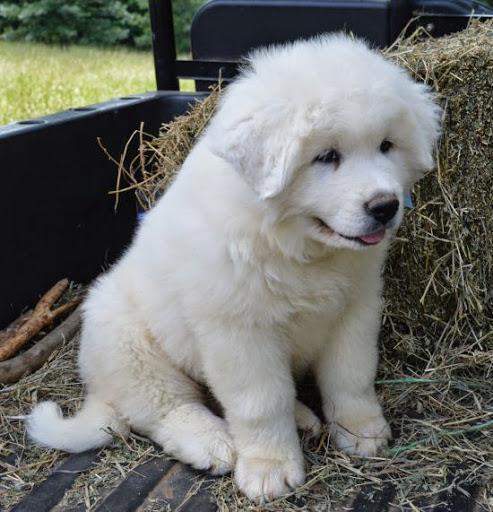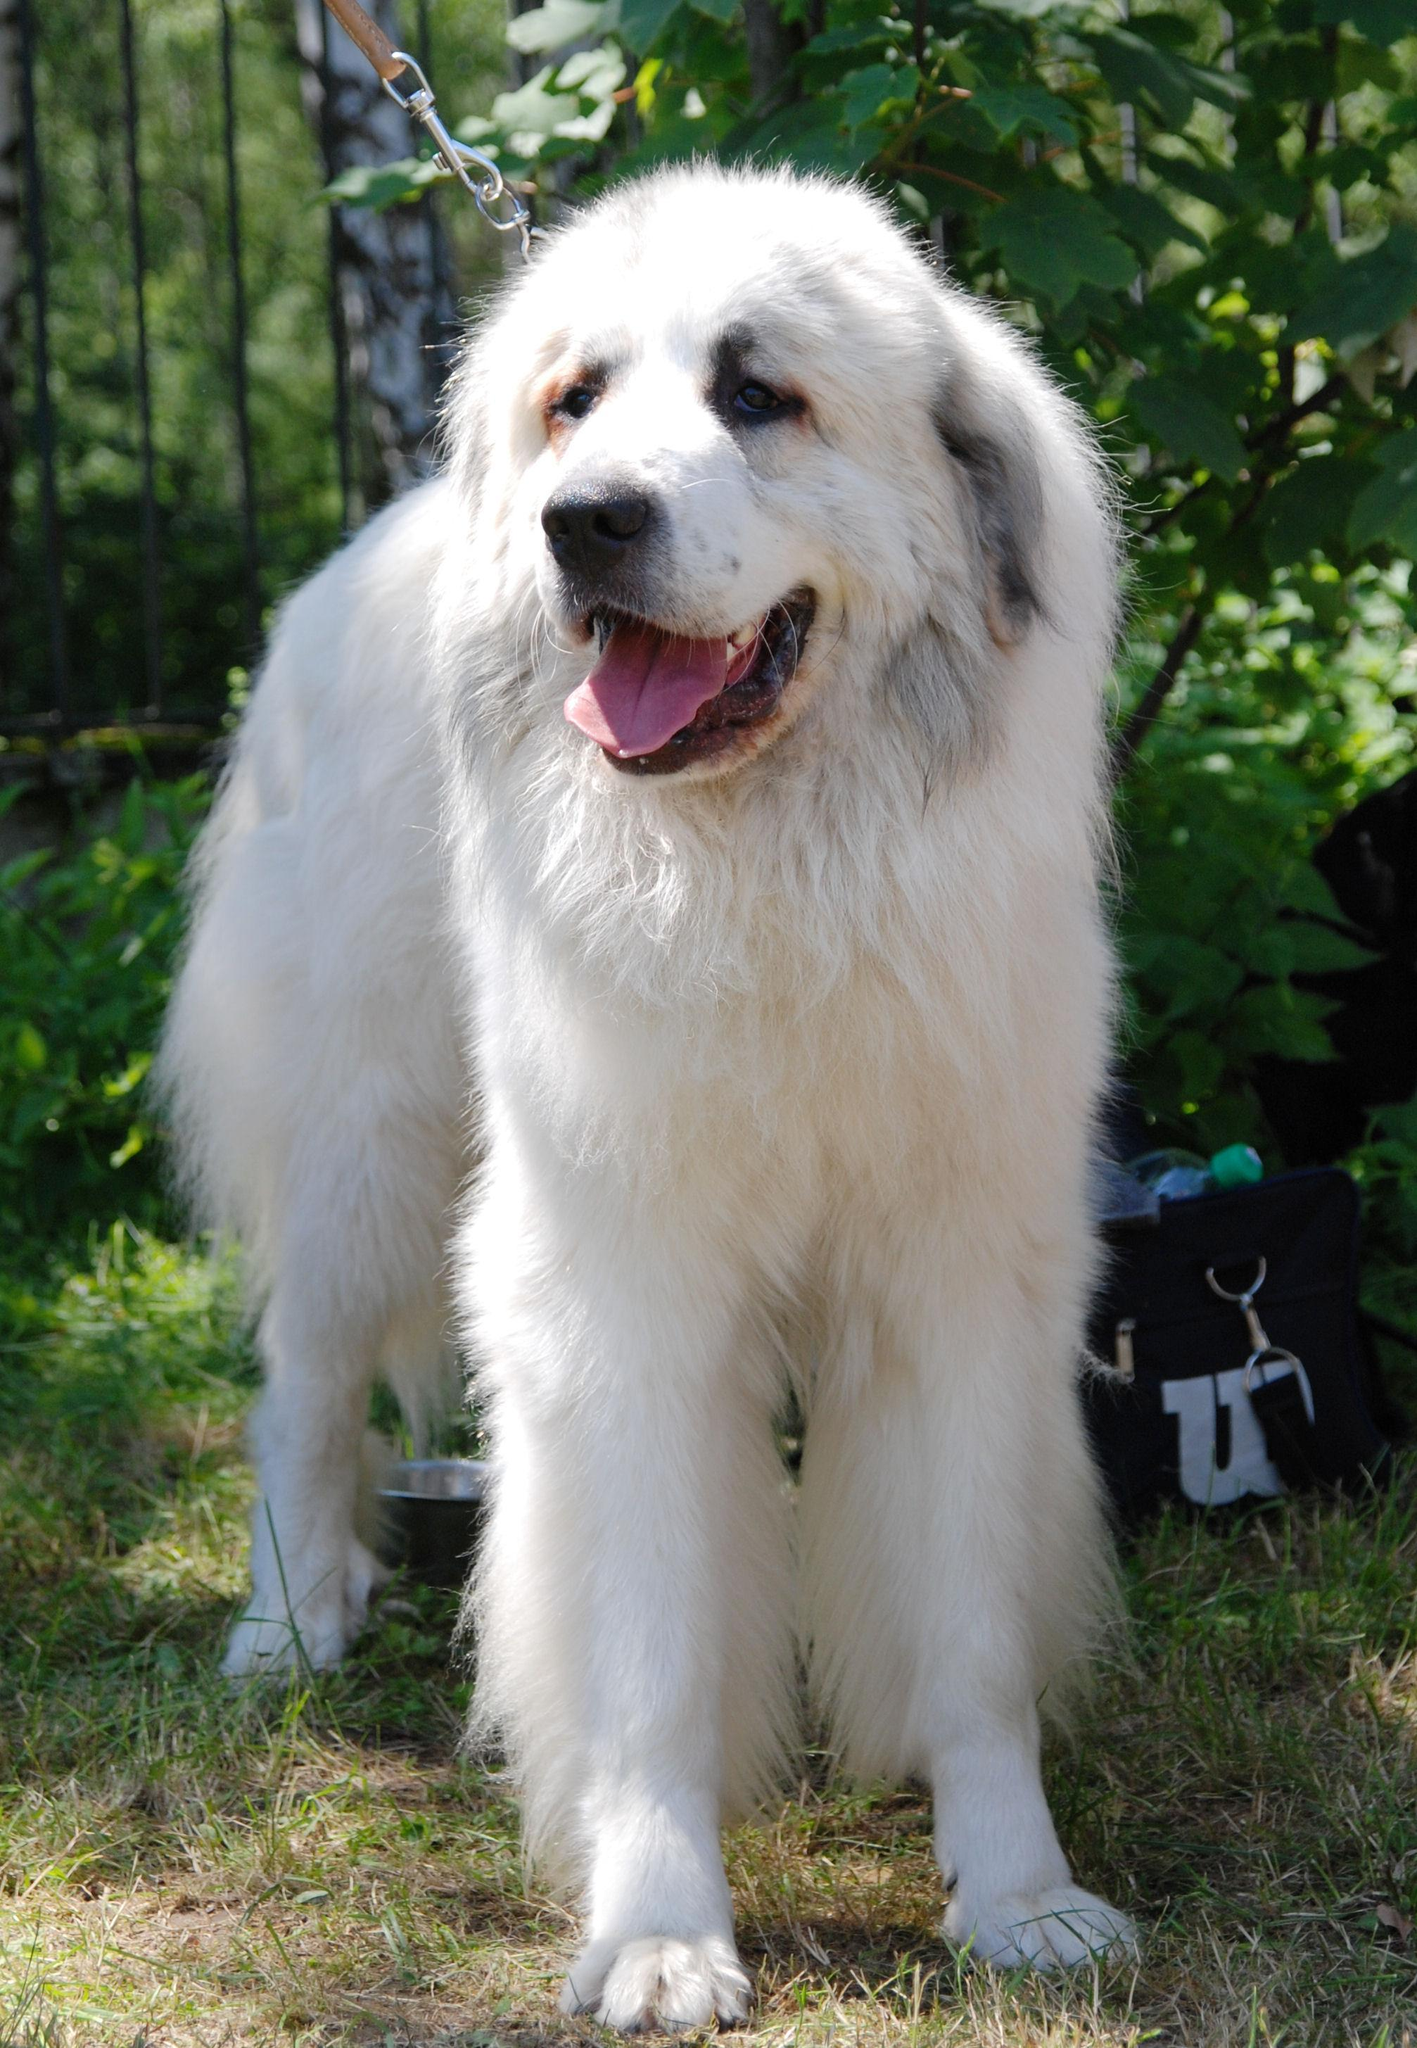The first image is the image on the left, the second image is the image on the right. Evaluate the accuracy of this statement regarding the images: "Right image shows exactly one white dog, which is standing on all fours on grass.". Is it true? Answer yes or no. Yes. 